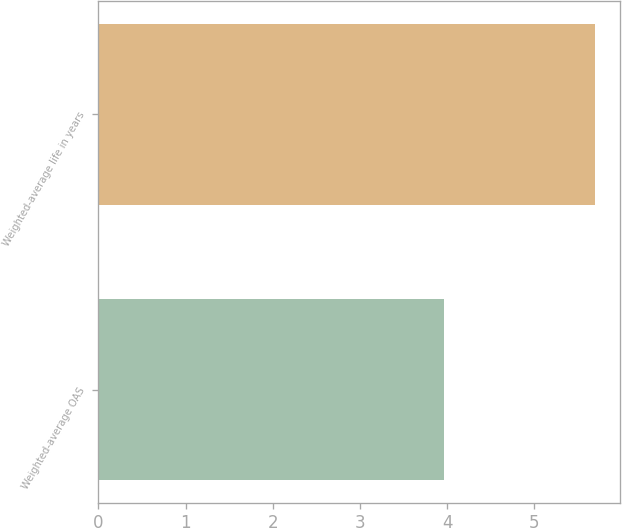<chart> <loc_0><loc_0><loc_500><loc_500><bar_chart><fcel>Weighted-average OAS<fcel>Weighted-average life in years<nl><fcel>3.97<fcel>5.7<nl></chart> 